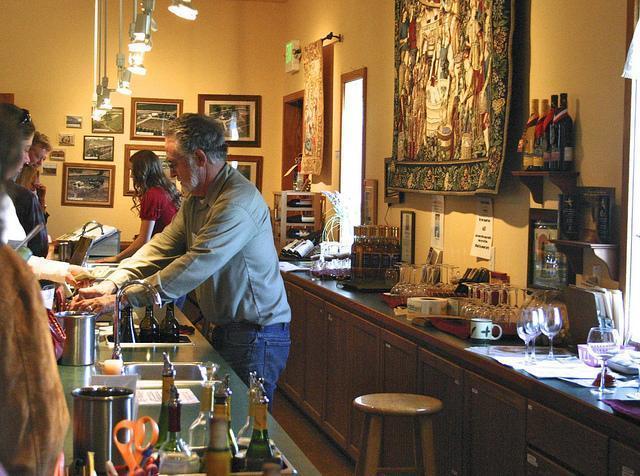How many people are in the picture?
Give a very brief answer. 5. 